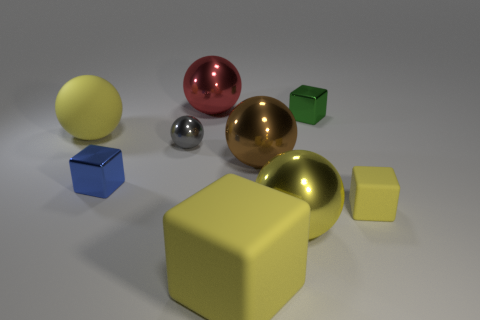Is there a yellow ball that has the same material as the tiny green block?
Your answer should be very brief. Yes. There is a thing that is behind the tiny blue object and left of the gray thing; what is its color?
Provide a succinct answer. Yellow. How many other things are there of the same color as the rubber ball?
Ensure brevity in your answer.  3. There is a yellow thing behind the tiny rubber block that is right of the tiny metal cube on the right side of the tiny blue thing; what is its material?
Provide a short and direct response. Rubber. What number of balls are yellow metal things or metal things?
Your answer should be very brief. 4. What number of blocks are to the right of the large ball that is behind the large matte thing left of the big red object?
Provide a succinct answer. 3. Do the blue metallic object and the red thing have the same shape?
Your answer should be very brief. No. Is the large red sphere that is behind the tiny gray shiny ball made of the same material as the block that is to the right of the green thing?
Your answer should be compact. No. What number of things are gray metallic things that are behind the large yellow cube or matte things that are right of the large red thing?
Offer a very short reply. 3. What number of brown metal spheres are there?
Your answer should be very brief. 1. 